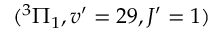Convert formula to latex. <formula><loc_0><loc_0><loc_500><loc_500>( ^ { 3 } \Pi _ { 1 } , v ^ { \prime } = 2 9 , J ^ { \prime } = 1 )</formula> 